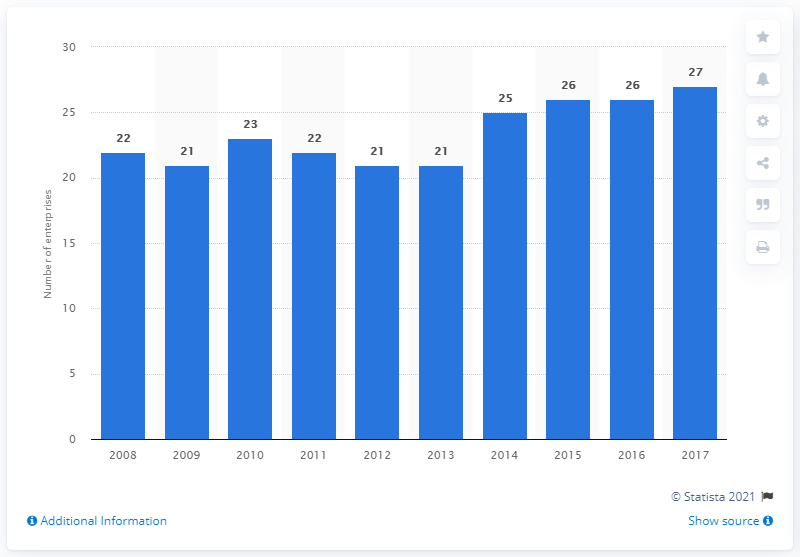List a handful of essential elements in this visual. In 2017, there were 27 enterprises operating in the cocoa, chocolate and sugar confectionery industry in Croatia. 